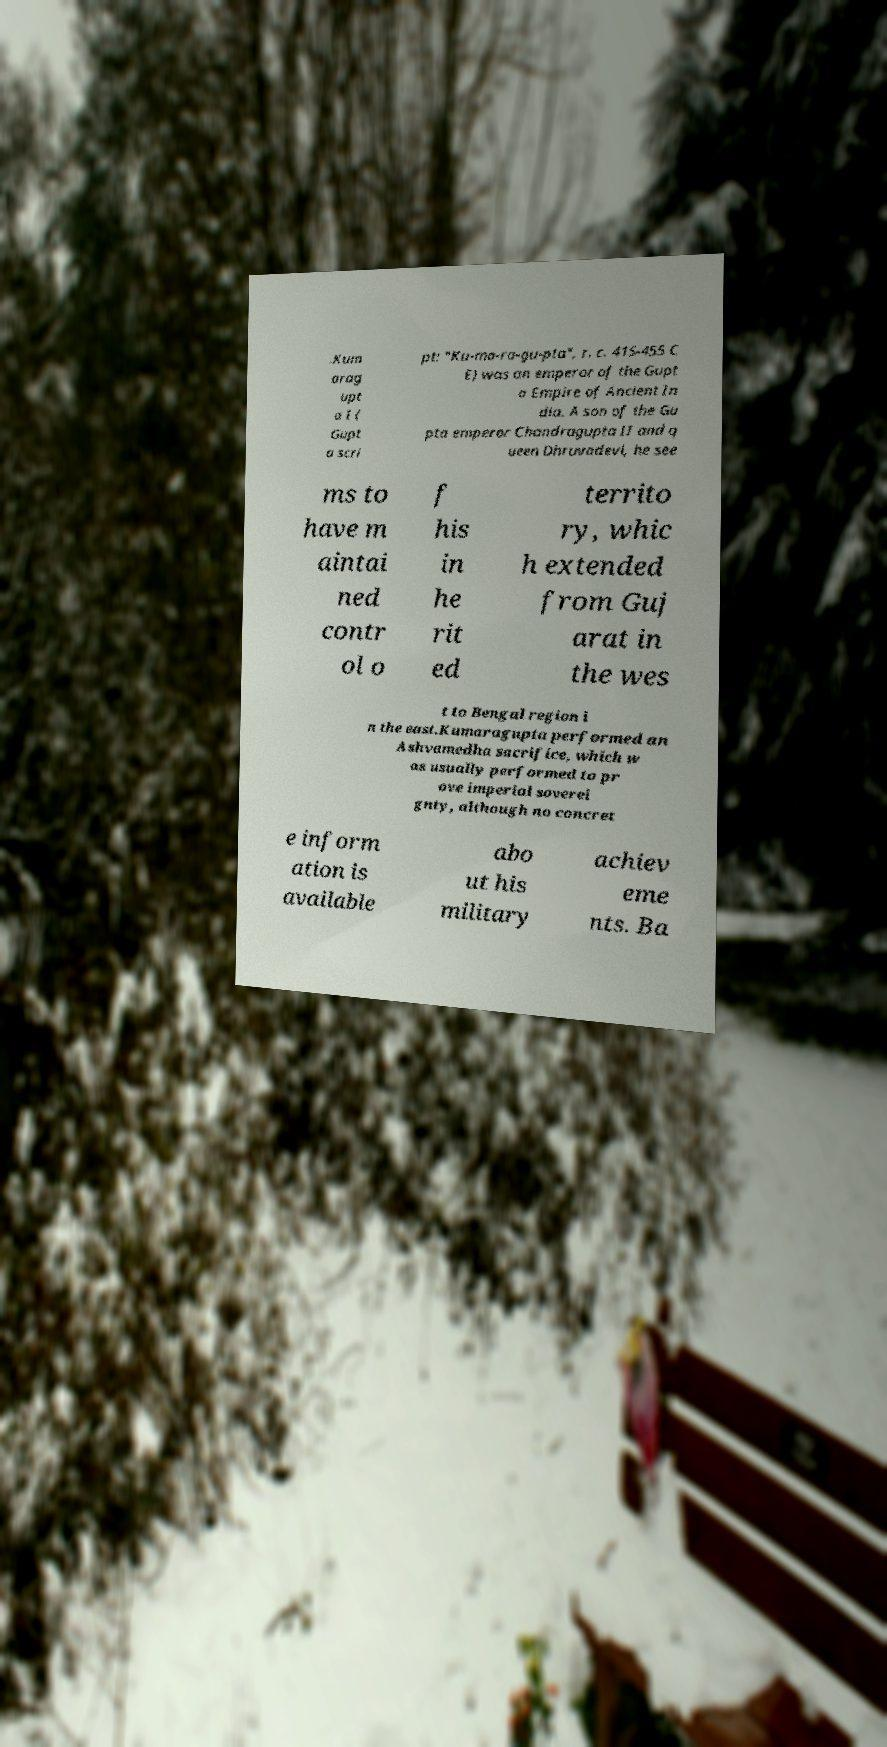Can you accurately transcribe the text from the provided image for me? .Kum arag upt a I ( Gupt a scri pt: "Ku-ma-ra-gu-pta", r. c. 415-455 C E) was an emperor of the Gupt a Empire of Ancient In dia. A son of the Gu pta emperor Chandragupta II and q ueen Dhruvadevi, he see ms to have m aintai ned contr ol o f his in he rit ed territo ry, whic h extended from Guj arat in the wes t to Bengal region i n the east.Kumaragupta performed an Ashvamedha sacrifice, which w as usually performed to pr ove imperial soverei gnty, although no concret e inform ation is available abo ut his military achiev eme nts. Ba 